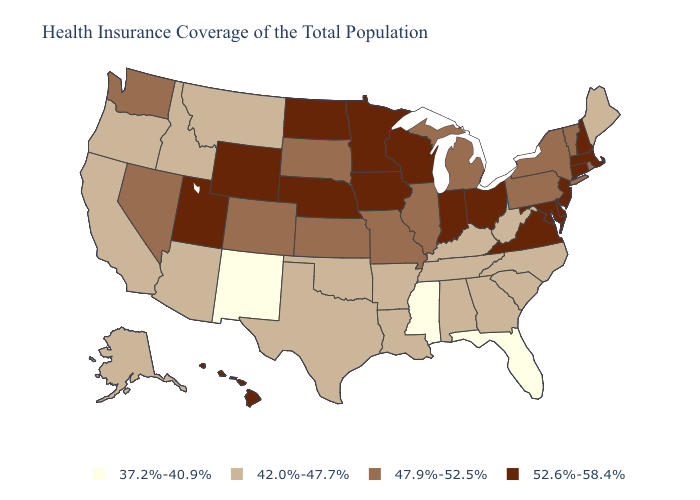What is the highest value in states that border Indiana?
Write a very short answer. 52.6%-58.4%. What is the value of Montana?
Quick response, please. 42.0%-47.7%. What is the lowest value in the Northeast?
Be succinct. 42.0%-47.7%. What is the value of Illinois?
Concise answer only. 47.9%-52.5%. Does the first symbol in the legend represent the smallest category?
Be succinct. Yes. What is the lowest value in the USA?
Answer briefly. 37.2%-40.9%. Among the states that border Rhode Island , which have the lowest value?
Short answer required. Connecticut, Massachusetts. Does Utah have the highest value in the West?
Write a very short answer. Yes. What is the value of Kansas?
Quick response, please. 47.9%-52.5%. Does the first symbol in the legend represent the smallest category?
Keep it brief. Yes. Does Minnesota have a higher value than Ohio?
Write a very short answer. No. What is the lowest value in the USA?
Short answer required. 37.2%-40.9%. What is the value of West Virginia?
Write a very short answer. 42.0%-47.7%. Name the states that have a value in the range 37.2%-40.9%?
Keep it brief. Florida, Mississippi, New Mexico. Among the states that border New York , which have the highest value?
Answer briefly. Connecticut, Massachusetts, New Jersey. 